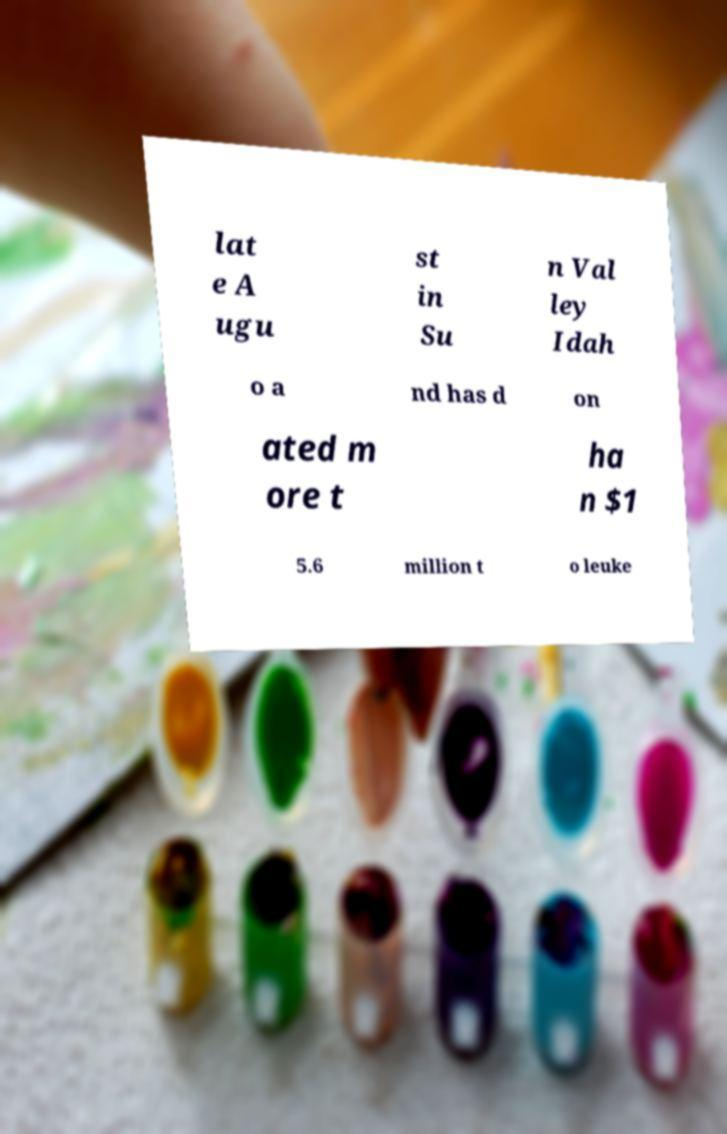What messages or text are displayed in this image? I need them in a readable, typed format. lat e A ugu st in Su n Val ley Idah o a nd has d on ated m ore t ha n $1 5.6 million t o leuke 